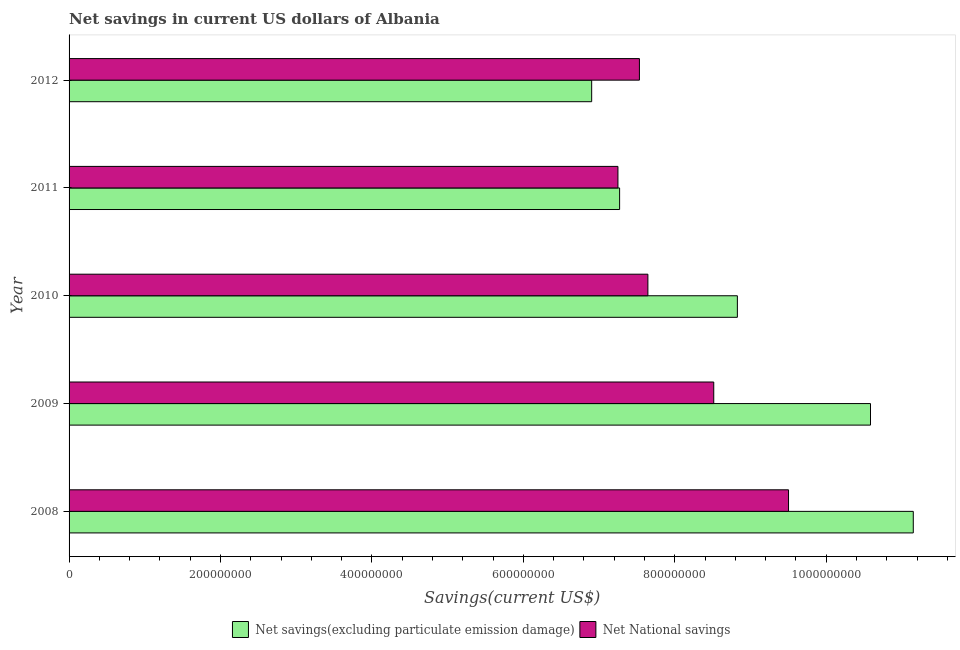How many groups of bars are there?
Keep it short and to the point. 5. Are the number of bars per tick equal to the number of legend labels?
Give a very brief answer. Yes. Are the number of bars on each tick of the Y-axis equal?
Offer a terse response. Yes. What is the net national savings in 2011?
Offer a terse response. 7.25e+08. Across all years, what is the maximum net savings(excluding particulate emission damage)?
Your response must be concise. 1.12e+09. Across all years, what is the minimum net national savings?
Offer a very short reply. 7.25e+08. In which year was the net national savings maximum?
Keep it short and to the point. 2008. In which year was the net national savings minimum?
Provide a short and direct response. 2011. What is the total net savings(excluding particulate emission damage) in the graph?
Make the answer very short. 4.47e+09. What is the difference between the net savings(excluding particulate emission damage) in 2011 and that in 2012?
Give a very brief answer. 3.69e+07. What is the difference between the net savings(excluding particulate emission damage) in 2010 and the net national savings in 2009?
Provide a short and direct response. 3.12e+07. What is the average net savings(excluding particulate emission damage) per year?
Provide a short and direct response. 8.95e+08. In the year 2011, what is the difference between the net savings(excluding particulate emission damage) and net national savings?
Your response must be concise. 2.20e+06. In how many years, is the net national savings greater than 1000000000 US$?
Ensure brevity in your answer.  0. What is the ratio of the net national savings in 2010 to that in 2011?
Ensure brevity in your answer.  1.05. Is the difference between the net national savings in 2010 and 2011 greater than the difference between the net savings(excluding particulate emission damage) in 2010 and 2011?
Your answer should be compact. No. What is the difference between the highest and the second highest net savings(excluding particulate emission damage)?
Make the answer very short. 5.65e+07. What is the difference between the highest and the lowest net national savings?
Offer a very short reply. 2.25e+08. Is the sum of the net national savings in 2009 and 2011 greater than the maximum net savings(excluding particulate emission damage) across all years?
Provide a short and direct response. Yes. What does the 2nd bar from the top in 2009 represents?
Provide a short and direct response. Net savings(excluding particulate emission damage). What does the 2nd bar from the bottom in 2011 represents?
Provide a succinct answer. Net National savings. What is the difference between two consecutive major ticks on the X-axis?
Offer a terse response. 2.00e+08. Are the values on the major ticks of X-axis written in scientific E-notation?
Provide a succinct answer. No. Does the graph contain any zero values?
Keep it short and to the point. No. Does the graph contain grids?
Offer a very short reply. No. What is the title of the graph?
Provide a short and direct response. Net savings in current US dollars of Albania. Does "Long-term debt" appear as one of the legend labels in the graph?
Ensure brevity in your answer.  No. What is the label or title of the X-axis?
Your answer should be compact. Savings(current US$). What is the Savings(current US$) in Net savings(excluding particulate emission damage) in 2008?
Offer a very short reply. 1.12e+09. What is the Savings(current US$) in Net National savings in 2008?
Provide a short and direct response. 9.50e+08. What is the Savings(current US$) of Net savings(excluding particulate emission damage) in 2009?
Ensure brevity in your answer.  1.06e+09. What is the Savings(current US$) in Net National savings in 2009?
Keep it short and to the point. 8.51e+08. What is the Savings(current US$) in Net savings(excluding particulate emission damage) in 2010?
Keep it short and to the point. 8.83e+08. What is the Savings(current US$) of Net National savings in 2010?
Provide a succinct answer. 7.64e+08. What is the Savings(current US$) in Net savings(excluding particulate emission damage) in 2011?
Keep it short and to the point. 7.27e+08. What is the Savings(current US$) in Net National savings in 2011?
Offer a terse response. 7.25e+08. What is the Savings(current US$) of Net savings(excluding particulate emission damage) in 2012?
Give a very brief answer. 6.90e+08. What is the Savings(current US$) of Net National savings in 2012?
Provide a short and direct response. 7.53e+08. Across all years, what is the maximum Savings(current US$) of Net savings(excluding particulate emission damage)?
Your answer should be very brief. 1.12e+09. Across all years, what is the maximum Savings(current US$) of Net National savings?
Your answer should be compact. 9.50e+08. Across all years, what is the minimum Savings(current US$) in Net savings(excluding particulate emission damage)?
Offer a terse response. 6.90e+08. Across all years, what is the minimum Savings(current US$) of Net National savings?
Your answer should be compact. 7.25e+08. What is the total Savings(current US$) in Net savings(excluding particulate emission damage) in the graph?
Offer a terse response. 4.47e+09. What is the total Savings(current US$) of Net National savings in the graph?
Provide a short and direct response. 4.04e+09. What is the difference between the Savings(current US$) of Net savings(excluding particulate emission damage) in 2008 and that in 2009?
Offer a terse response. 5.65e+07. What is the difference between the Savings(current US$) of Net National savings in 2008 and that in 2009?
Make the answer very short. 9.88e+07. What is the difference between the Savings(current US$) of Net savings(excluding particulate emission damage) in 2008 and that in 2010?
Your answer should be compact. 2.32e+08. What is the difference between the Savings(current US$) in Net National savings in 2008 and that in 2010?
Your answer should be very brief. 1.86e+08. What is the difference between the Savings(current US$) in Net savings(excluding particulate emission damage) in 2008 and that in 2011?
Your answer should be very brief. 3.88e+08. What is the difference between the Savings(current US$) in Net National savings in 2008 and that in 2011?
Ensure brevity in your answer.  2.25e+08. What is the difference between the Savings(current US$) in Net savings(excluding particulate emission damage) in 2008 and that in 2012?
Provide a short and direct response. 4.25e+08. What is the difference between the Savings(current US$) in Net National savings in 2008 and that in 2012?
Offer a very short reply. 1.97e+08. What is the difference between the Savings(current US$) in Net savings(excluding particulate emission damage) in 2009 and that in 2010?
Your answer should be very brief. 1.76e+08. What is the difference between the Savings(current US$) in Net National savings in 2009 and that in 2010?
Your answer should be very brief. 8.70e+07. What is the difference between the Savings(current US$) of Net savings(excluding particulate emission damage) in 2009 and that in 2011?
Your answer should be compact. 3.31e+08. What is the difference between the Savings(current US$) of Net National savings in 2009 and that in 2011?
Offer a terse response. 1.27e+08. What is the difference between the Savings(current US$) in Net savings(excluding particulate emission damage) in 2009 and that in 2012?
Provide a succinct answer. 3.68e+08. What is the difference between the Savings(current US$) of Net National savings in 2009 and that in 2012?
Provide a succinct answer. 9.82e+07. What is the difference between the Savings(current US$) in Net savings(excluding particulate emission damage) in 2010 and that in 2011?
Your answer should be compact. 1.56e+08. What is the difference between the Savings(current US$) of Net National savings in 2010 and that in 2011?
Your response must be concise. 3.96e+07. What is the difference between the Savings(current US$) in Net savings(excluding particulate emission damage) in 2010 and that in 2012?
Provide a succinct answer. 1.92e+08. What is the difference between the Savings(current US$) in Net National savings in 2010 and that in 2012?
Ensure brevity in your answer.  1.12e+07. What is the difference between the Savings(current US$) in Net savings(excluding particulate emission damage) in 2011 and that in 2012?
Provide a short and direct response. 3.69e+07. What is the difference between the Savings(current US$) in Net National savings in 2011 and that in 2012?
Your answer should be very brief. -2.84e+07. What is the difference between the Savings(current US$) of Net savings(excluding particulate emission damage) in 2008 and the Savings(current US$) of Net National savings in 2009?
Keep it short and to the point. 2.64e+08. What is the difference between the Savings(current US$) in Net savings(excluding particulate emission damage) in 2008 and the Savings(current US$) in Net National savings in 2010?
Offer a terse response. 3.51e+08. What is the difference between the Savings(current US$) in Net savings(excluding particulate emission damage) in 2008 and the Savings(current US$) in Net National savings in 2011?
Offer a terse response. 3.90e+08. What is the difference between the Savings(current US$) in Net savings(excluding particulate emission damage) in 2008 and the Savings(current US$) in Net National savings in 2012?
Your answer should be compact. 3.62e+08. What is the difference between the Savings(current US$) of Net savings(excluding particulate emission damage) in 2009 and the Savings(current US$) of Net National savings in 2010?
Give a very brief answer. 2.94e+08. What is the difference between the Savings(current US$) of Net savings(excluding particulate emission damage) in 2009 and the Savings(current US$) of Net National savings in 2011?
Give a very brief answer. 3.34e+08. What is the difference between the Savings(current US$) of Net savings(excluding particulate emission damage) in 2009 and the Savings(current US$) of Net National savings in 2012?
Keep it short and to the point. 3.05e+08. What is the difference between the Savings(current US$) of Net savings(excluding particulate emission damage) in 2010 and the Savings(current US$) of Net National savings in 2011?
Offer a terse response. 1.58e+08. What is the difference between the Savings(current US$) of Net savings(excluding particulate emission damage) in 2010 and the Savings(current US$) of Net National savings in 2012?
Keep it short and to the point. 1.29e+08. What is the difference between the Savings(current US$) in Net savings(excluding particulate emission damage) in 2011 and the Savings(current US$) in Net National savings in 2012?
Provide a short and direct response. -2.62e+07. What is the average Savings(current US$) of Net savings(excluding particulate emission damage) per year?
Make the answer very short. 8.95e+08. What is the average Savings(current US$) in Net National savings per year?
Keep it short and to the point. 8.09e+08. In the year 2008, what is the difference between the Savings(current US$) of Net savings(excluding particulate emission damage) and Savings(current US$) of Net National savings?
Ensure brevity in your answer.  1.65e+08. In the year 2009, what is the difference between the Savings(current US$) of Net savings(excluding particulate emission damage) and Savings(current US$) of Net National savings?
Keep it short and to the point. 2.07e+08. In the year 2010, what is the difference between the Savings(current US$) in Net savings(excluding particulate emission damage) and Savings(current US$) in Net National savings?
Your response must be concise. 1.18e+08. In the year 2011, what is the difference between the Savings(current US$) of Net savings(excluding particulate emission damage) and Savings(current US$) of Net National savings?
Keep it short and to the point. 2.20e+06. In the year 2012, what is the difference between the Savings(current US$) of Net savings(excluding particulate emission damage) and Savings(current US$) of Net National savings?
Offer a very short reply. -6.31e+07. What is the ratio of the Savings(current US$) in Net savings(excluding particulate emission damage) in 2008 to that in 2009?
Your answer should be compact. 1.05. What is the ratio of the Savings(current US$) in Net National savings in 2008 to that in 2009?
Give a very brief answer. 1.12. What is the ratio of the Savings(current US$) of Net savings(excluding particulate emission damage) in 2008 to that in 2010?
Keep it short and to the point. 1.26. What is the ratio of the Savings(current US$) of Net National savings in 2008 to that in 2010?
Keep it short and to the point. 1.24. What is the ratio of the Savings(current US$) in Net savings(excluding particulate emission damage) in 2008 to that in 2011?
Give a very brief answer. 1.53. What is the ratio of the Savings(current US$) in Net National savings in 2008 to that in 2011?
Ensure brevity in your answer.  1.31. What is the ratio of the Savings(current US$) of Net savings(excluding particulate emission damage) in 2008 to that in 2012?
Provide a succinct answer. 1.62. What is the ratio of the Savings(current US$) in Net National savings in 2008 to that in 2012?
Provide a succinct answer. 1.26. What is the ratio of the Savings(current US$) of Net savings(excluding particulate emission damage) in 2009 to that in 2010?
Your response must be concise. 1.2. What is the ratio of the Savings(current US$) of Net National savings in 2009 to that in 2010?
Ensure brevity in your answer.  1.11. What is the ratio of the Savings(current US$) in Net savings(excluding particulate emission damage) in 2009 to that in 2011?
Offer a very short reply. 1.46. What is the ratio of the Savings(current US$) in Net National savings in 2009 to that in 2011?
Your answer should be very brief. 1.17. What is the ratio of the Savings(current US$) of Net savings(excluding particulate emission damage) in 2009 to that in 2012?
Make the answer very short. 1.53. What is the ratio of the Savings(current US$) of Net National savings in 2009 to that in 2012?
Keep it short and to the point. 1.13. What is the ratio of the Savings(current US$) of Net savings(excluding particulate emission damage) in 2010 to that in 2011?
Provide a short and direct response. 1.21. What is the ratio of the Savings(current US$) in Net National savings in 2010 to that in 2011?
Your answer should be very brief. 1.05. What is the ratio of the Savings(current US$) of Net savings(excluding particulate emission damage) in 2010 to that in 2012?
Your response must be concise. 1.28. What is the ratio of the Savings(current US$) of Net National savings in 2010 to that in 2012?
Offer a very short reply. 1.01. What is the ratio of the Savings(current US$) of Net savings(excluding particulate emission damage) in 2011 to that in 2012?
Keep it short and to the point. 1.05. What is the ratio of the Savings(current US$) in Net National savings in 2011 to that in 2012?
Offer a terse response. 0.96. What is the difference between the highest and the second highest Savings(current US$) in Net savings(excluding particulate emission damage)?
Offer a very short reply. 5.65e+07. What is the difference between the highest and the second highest Savings(current US$) of Net National savings?
Keep it short and to the point. 9.88e+07. What is the difference between the highest and the lowest Savings(current US$) in Net savings(excluding particulate emission damage)?
Ensure brevity in your answer.  4.25e+08. What is the difference between the highest and the lowest Savings(current US$) in Net National savings?
Offer a terse response. 2.25e+08. 